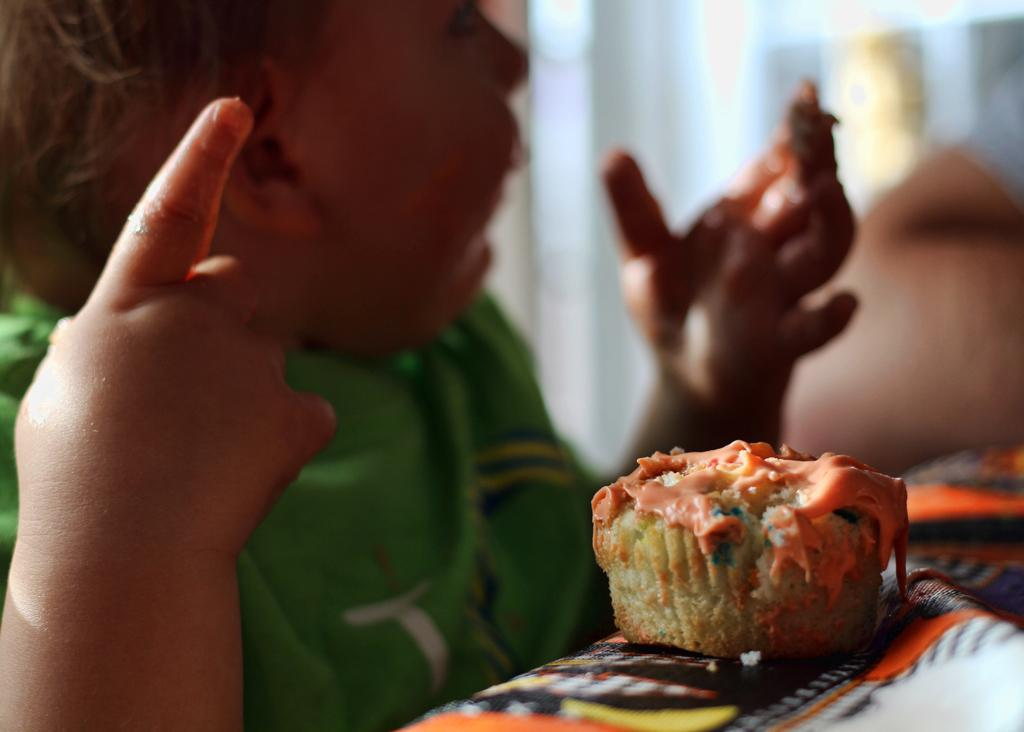What is the main subject of the image? There is a baby girl in the image. What is the baby girl wearing? The baby girl is wearing a green jacket. What else can be seen in the image besides the baby girl? There is a cake in the image. Where is the cake located? The cake is on a table. Can you describe the background of the image? There is a blurred image in the background of the image. What sound can be heard coming from the appliance in the image? There is no appliance present in the image, so it's not possible to determine what sound might be heard. 